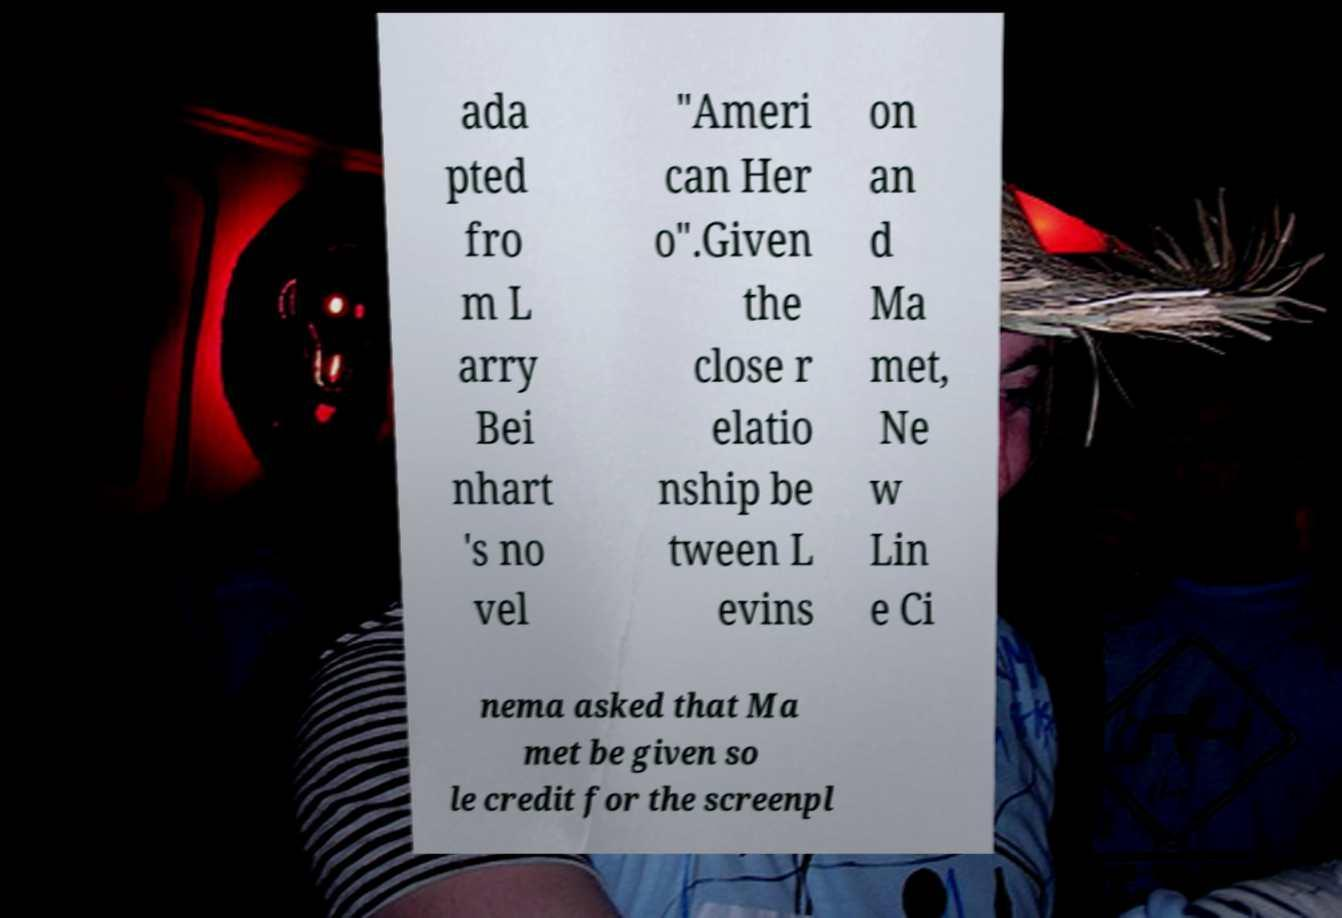Can you read and provide the text displayed in the image?This photo seems to have some interesting text. Can you extract and type it out for me? ada pted fro m L arry Bei nhart 's no vel "Ameri can Her o".Given the close r elatio nship be tween L evins on an d Ma met, Ne w Lin e Ci nema asked that Ma met be given so le credit for the screenpl 